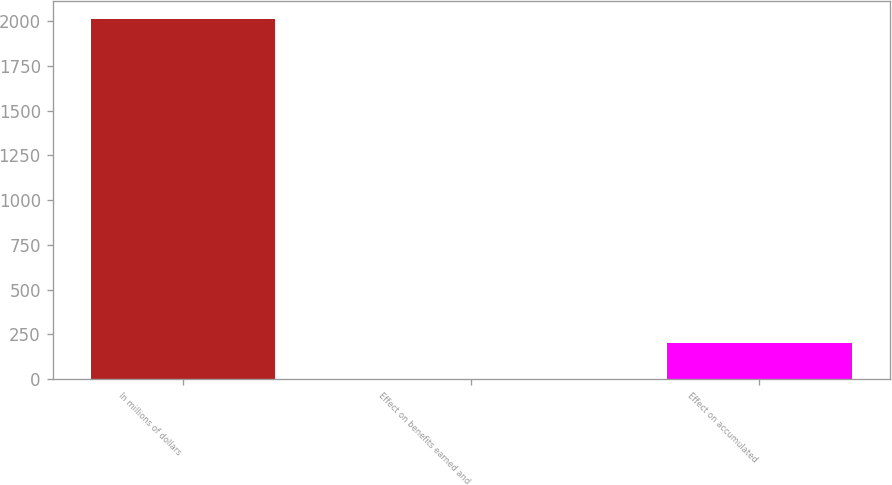Convert chart. <chart><loc_0><loc_0><loc_500><loc_500><bar_chart><fcel>In millions of dollars<fcel>Effect on benefits earned and<fcel>Effect on accumulated<nl><fcel>2015<fcel>2<fcel>203.3<nl></chart> 